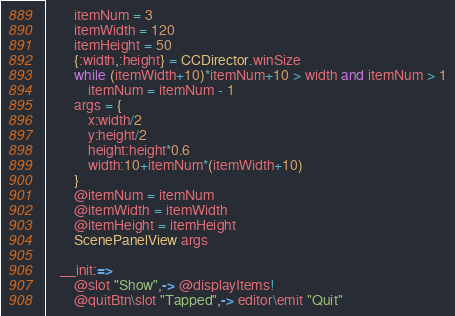Convert code to text. <code><loc_0><loc_0><loc_500><loc_500><_MoonScript_>		itemNum = 3
		itemWidth = 120
		itemHeight = 50
		{:width,:height} = CCDirector.winSize
		while (itemWidth+10)*itemNum+10 > width and itemNum > 1
			itemNum = itemNum - 1
		args = {
			x:width/2
			y:height/2
			height:height*0.6
			width:10+itemNum*(itemWidth+10)
		}
		@itemNum = itemNum
		@itemWidth = itemWidth
		@itemHeight = itemHeight
		ScenePanelView args

	__init:=>
		@slot "Show",-> @displayItems!
		@quitBtn\slot "Tapped",-> editor\emit "Quit"
</code> 